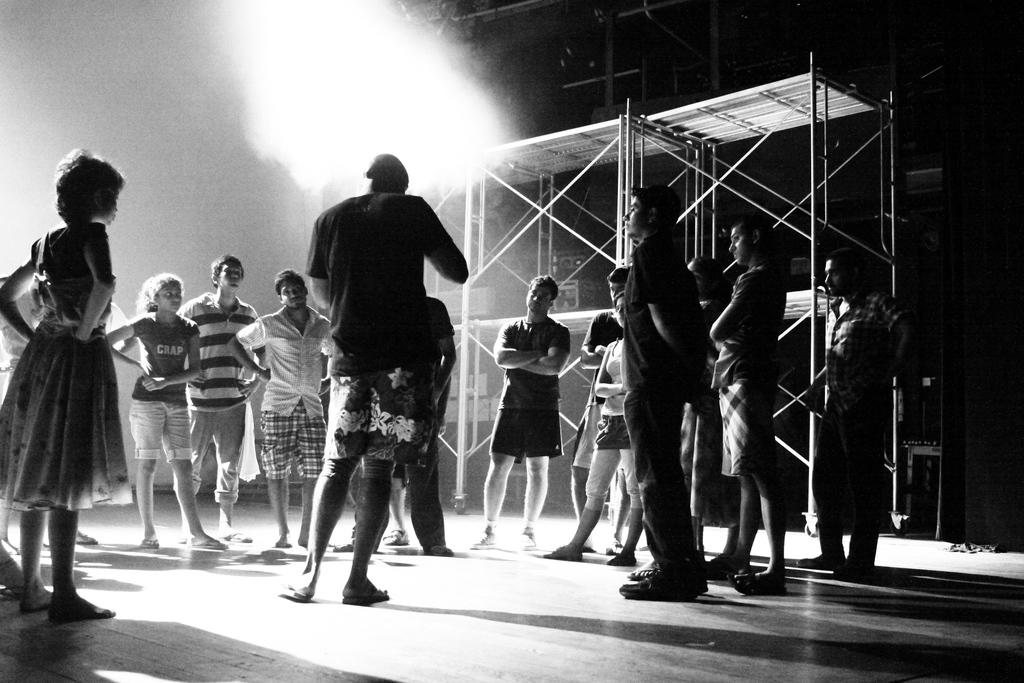What is the color scheme of the image? The image is black and white. What can be seen in the image? There are people standing in the image. What is visible in the background of the image? There is an iron frame in the background of the image. What type of waves can be seen in the image? There are no waves present in the image. 